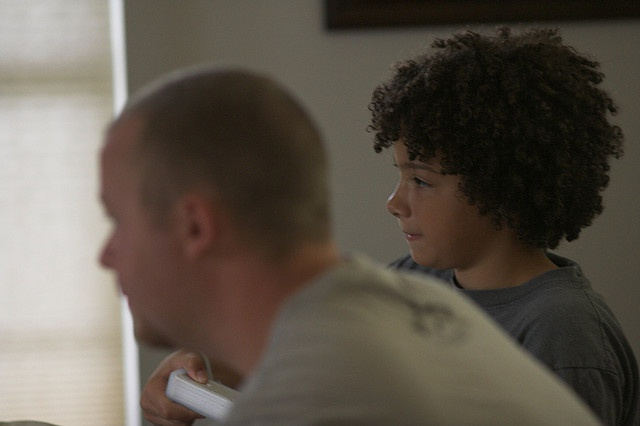Describe the objects in this image and their specific colors. I can see people in silver, gray, black, and maroon tones, people in silver, black, maroon, and gray tones, and remote in silver, darkgray, and gray tones in this image. 